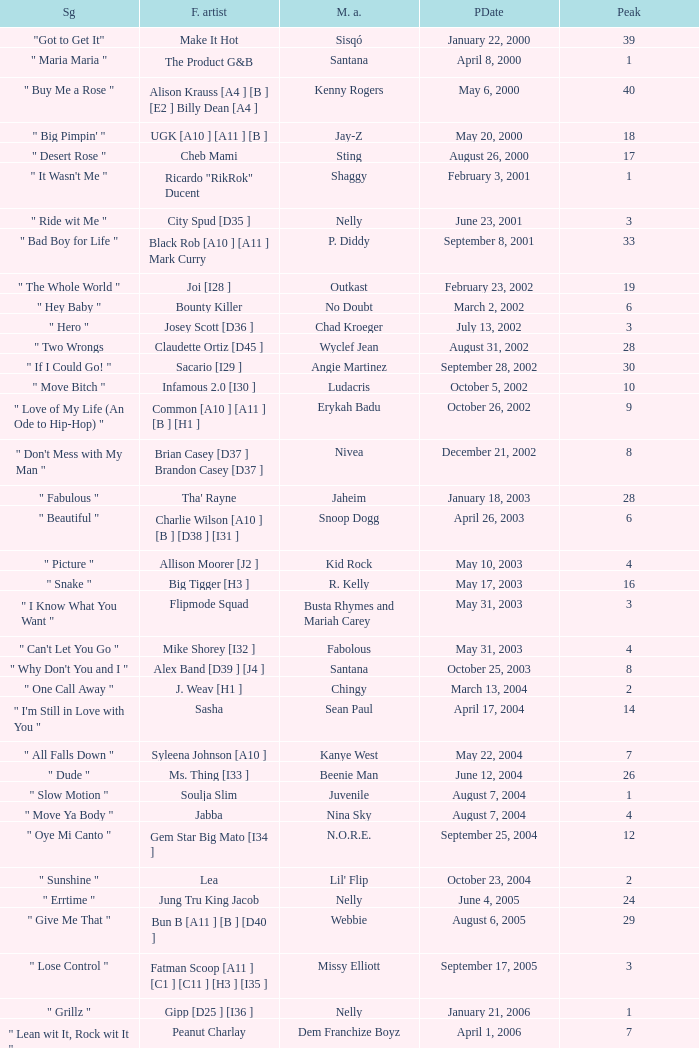What was the peak date of Kelis's song? August 6, 2006. 